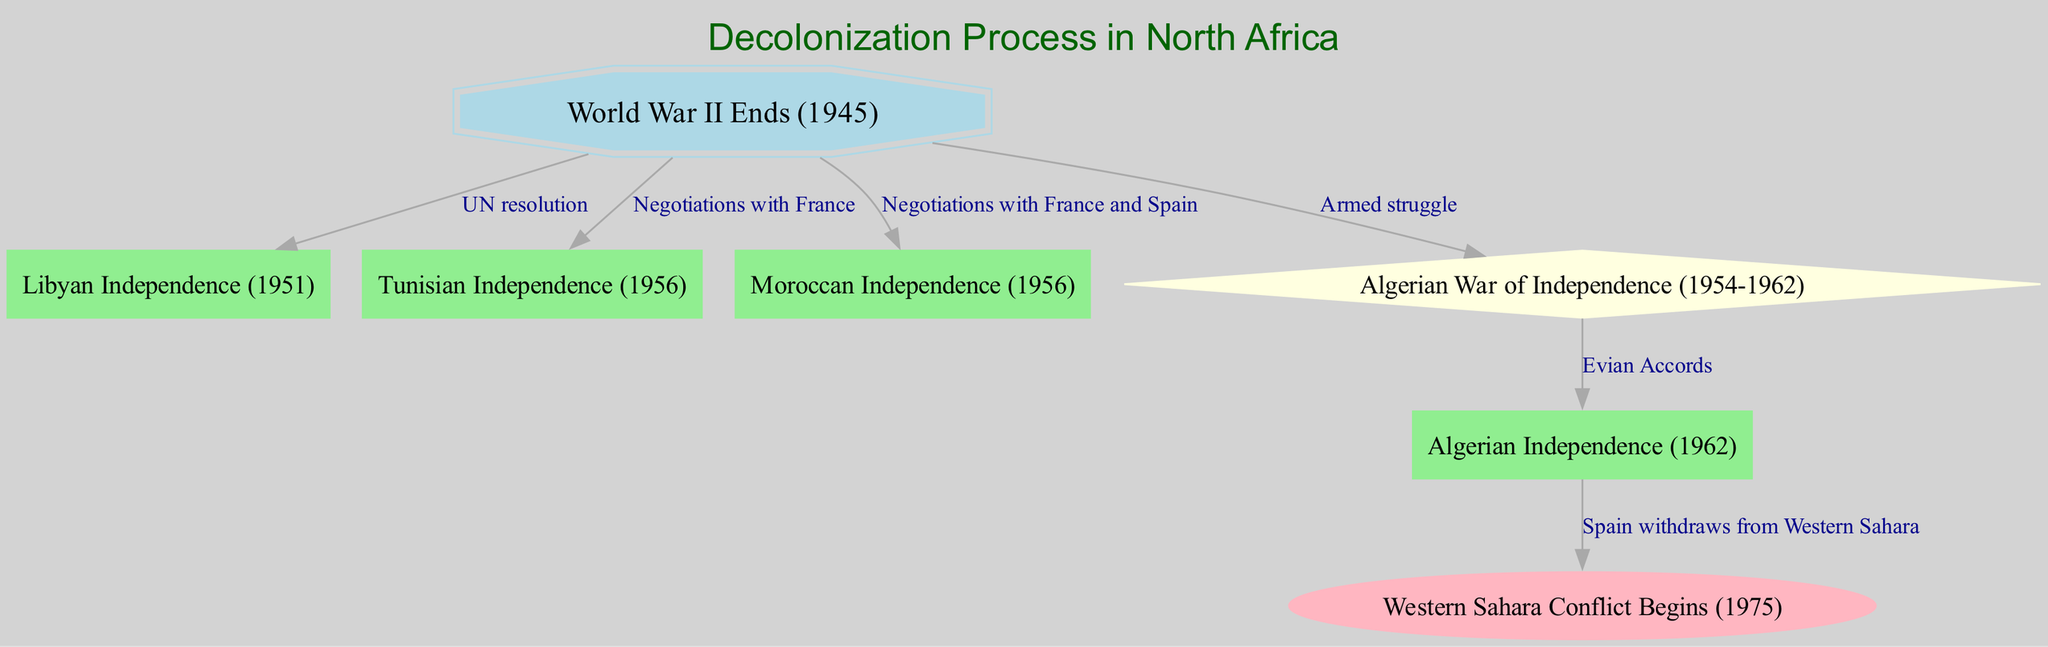What is the starting point of the decolonization process shown in the diagram? The starting point node is labeled "World War II Ends (1945)", which is clearly marked at the top of the flowchart as the initial event leading to subsequent decolonization actions.
Answer: World War II Ends (1945) Which country gained independence first according to the diagram? The first independence event listed in the nodes is "Libyan Independence (1951)", which is directly connected to the starting point with an edge labeled "UN resolution".
Answer: Libyan Independence (1951) How many independence events are depicted in the diagram? Counting the nodes representing independence events, we find "Libyan Independence", "Tunisian Independence", "Moroccan Independence", and "Algerian Independence", totaling four such events.
Answer: Four What type of struggle is associated with Algerian independence? The edge leading from "World War II Ends (1945)" to "Algerian War of Independence (1954-1962)" is labeled "Armed struggle", indicating the nature of the conflict necessary for achieving independence.
Answer: Armed struggle What document led to Algerian independence in the diagram? The diagram shows that "Evian Accords" connects the "Algerian War of Independence (1954-1962)" to "Algerian Independence (1962)", indicating that this document was a key factor in the independence process.
Answer: Evian Accords What event initiated the Western Sahara conflict according to the flowchart? The diagram states that the "Western Sahara Conflict Begins (1975)" is connected to "Algerian Independence (1962)", which suggests that developing tensions after Algerian independence led to this conflict starting.
Answer: Western Sahara Conflict Begins (1975) Which two countries were involved in negotiations for Moroccan independence? The edge from "World War II Ends (1945)" to "Moroccan Independence (1956)" is labeled "Negotiations with France and Spain", indicating these two countries' involvement in the process.
Answer: France and Spain What major event does the diagram associate with the transition from the Algerian War of Independence to official independence? The flowchart connects "Algerian War of Independence (1954-1962)" to "Algerian Independence (1962)" through the "Evian Accords", highlighting the critical role of this agreement in achieving the independence of Algeria.
Answer: Evian Accords 